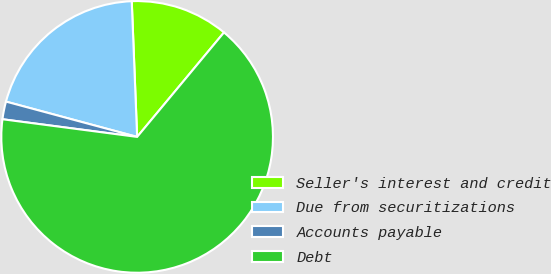Convert chart to OTSL. <chart><loc_0><loc_0><loc_500><loc_500><pie_chart><fcel>Seller's interest and credit<fcel>Due from securitizations<fcel>Accounts payable<fcel>Debt<nl><fcel>11.67%<fcel>20.18%<fcel>2.11%<fcel>66.03%<nl></chart> 